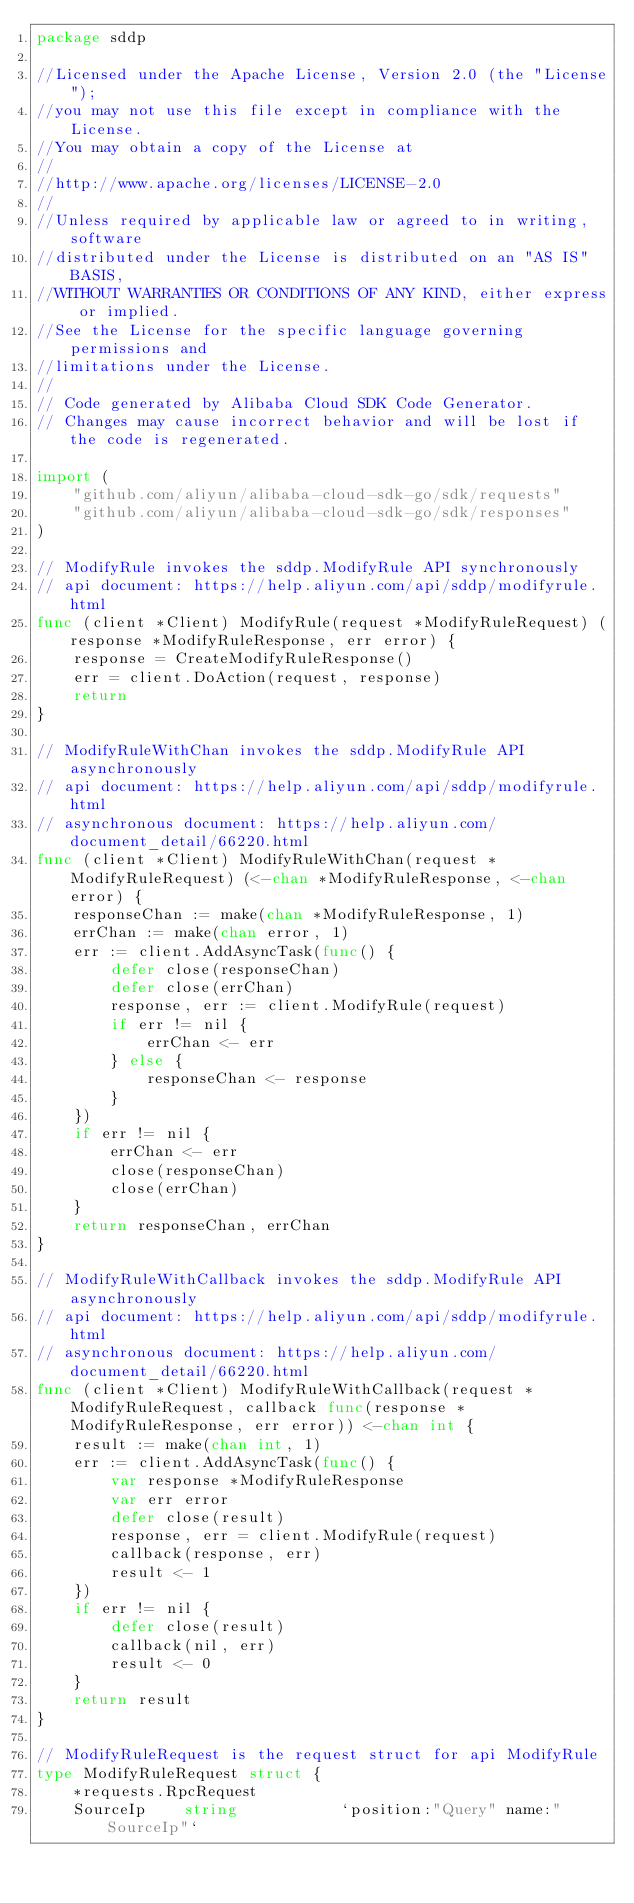Convert code to text. <code><loc_0><loc_0><loc_500><loc_500><_Go_>package sddp

//Licensed under the Apache License, Version 2.0 (the "License");
//you may not use this file except in compliance with the License.
//You may obtain a copy of the License at
//
//http://www.apache.org/licenses/LICENSE-2.0
//
//Unless required by applicable law or agreed to in writing, software
//distributed under the License is distributed on an "AS IS" BASIS,
//WITHOUT WARRANTIES OR CONDITIONS OF ANY KIND, either express or implied.
//See the License for the specific language governing permissions and
//limitations under the License.
//
// Code generated by Alibaba Cloud SDK Code Generator.
// Changes may cause incorrect behavior and will be lost if the code is regenerated.

import (
	"github.com/aliyun/alibaba-cloud-sdk-go/sdk/requests"
	"github.com/aliyun/alibaba-cloud-sdk-go/sdk/responses"
)

// ModifyRule invokes the sddp.ModifyRule API synchronously
// api document: https://help.aliyun.com/api/sddp/modifyrule.html
func (client *Client) ModifyRule(request *ModifyRuleRequest) (response *ModifyRuleResponse, err error) {
	response = CreateModifyRuleResponse()
	err = client.DoAction(request, response)
	return
}

// ModifyRuleWithChan invokes the sddp.ModifyRule API asynchronously
// api document: https://help.aliyun.com/api/sddp/modifyrule.html
// asynchronous document: https://help.aliyun.com/document_detail/66220.html
func (client *Client) ModifyRuleWithChan(request *ModifyRuleRequest) (<-chan *ModifyRuleResponse, <-chan error) {
	responseChan := make(chan *ModifyRuleResponse, 1)
	errChan := make(chan error, 1)
	err := client.AddAsyncTask(func() {
		defer close(responseChan)
		defer close(errChan)
		response, err := client.ModifyRule(request)
		if err != nil {
			errChan <- err
		} else {
			responseChan <- response
		}
	})
	if err != nil {
		errChan <- err
		close(responseChan)
		close(errChan)
	}
	return responseChan, errChan
}

// ModifyRuleWithCallback invokes the sddp.ModifyRule API asynchronously
// api document: https://help.aliyun.com/api/sddp/modifyrule.html
// asynchronous document: https://help.aliyun.com/document_detail/66220.html
func (client *Client) ModifyRuleWithCallback(request *ModifyRuleRequest, callback func(response *ModifyRuleResponse, err error)) <-chan int {
	result := make(chan int, 1)
	err := client.AddAsyncTask(func() {
		var response *ModifyRuleResponse
		var err error
		defer close(result)
		response, err = client.ModifyRule(request)
		callback(response, err)
		result <- 1
	})
	if err != nil {
		defer close(result)
		callback(nil, err)
		result <- 0
	}
	return result
}

// ModifyRuleRequest is the request struct for api ModifyRule
type ModifyRuleRequest struct {
	*requests.RpcRequest
	SourceIp    string           `position:"Query" name:"SourceIp"`</code> 